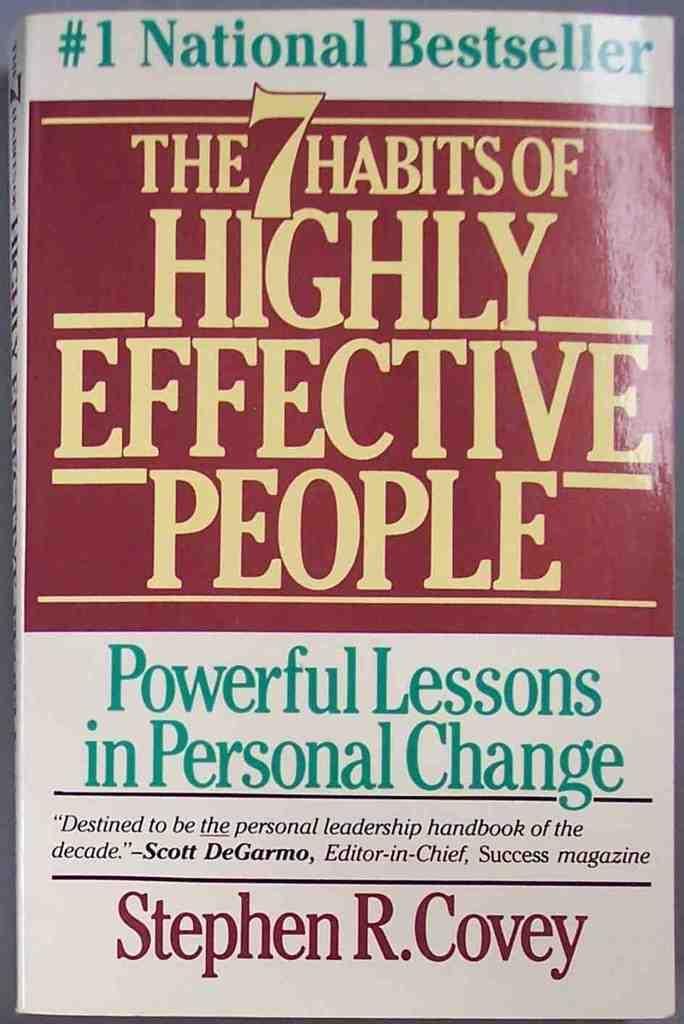<image>
Present a compact description of the photo's key features. the cover of a book called 'the 7 habits of highly effective people' 